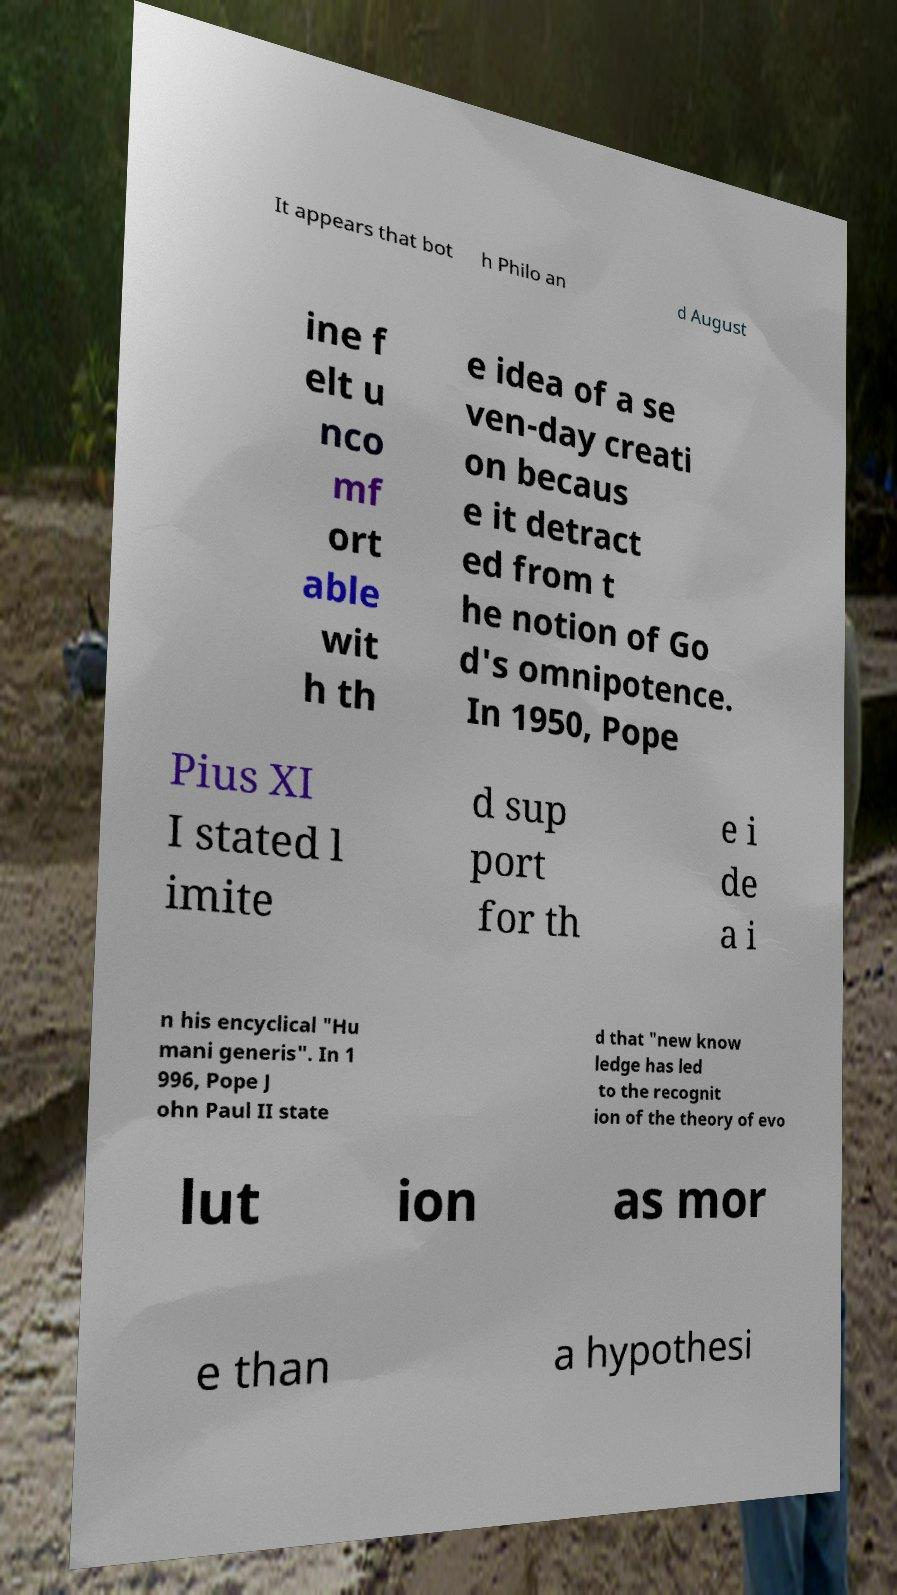What messages or text are displayed in this image? I need them in a readable, typed format. It appears that bot h Philo an d August ine f elt u nco mf ort able wit h th e idea of a se ven-day creati on becaus e it detract ed from t he notion of Go d's omnipotence. In 1950, Pope Pius XI I stated l imite d sup port for th e i de a i n his encyclical "Hu mani generis". In 1 996, Pope J ohn Paul II state d that "new know ledge has led to the recognit ion of the theory of evo lut ion as mor e than a hypothesi 